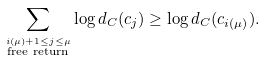Convert formula to latex. <formula><loc_0><loc_0><loc_500><loc_500>\sum _ { \stackrel { i ( \mu ) + 1 \leq j \leq \mu } { \text {free return} } } \log d _ { C } ( c _ { j } ) \geq \log d _ { C } ( c _ { i ( \mu ) } ) .</formula> 